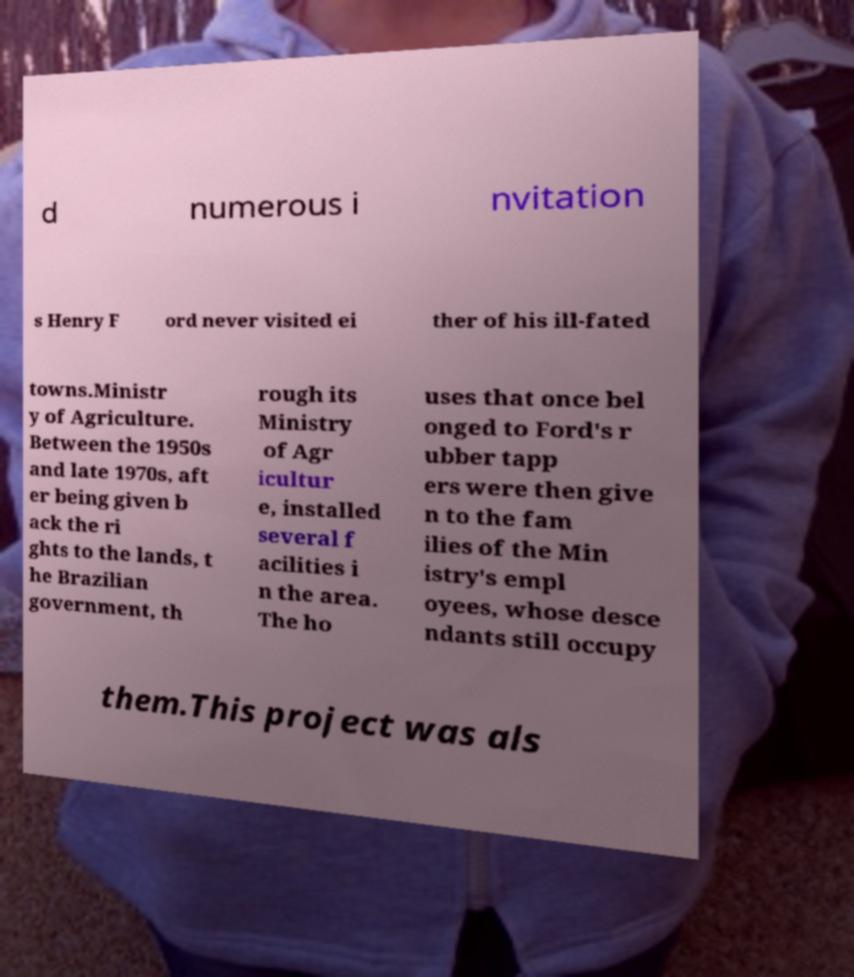Please identify and transcribe the text found in this image. d numerous i nvitation s Henry F ord never visited ei ther of his ill-fated towns.Ministr y of Agriculture. Between the 1950s and late 1970s, aft er being given b ack the ri ghts to the lands, t he Brazilian government, th rough its Ministry of Agr icultur e, installed several f acilities i n the area. The ho uses that once bel onged to Ford's r ubber tapp ers were then give n to the fam ilies of the Min istry's empl oyees, whose desce ndants still occupy them.This project was als 